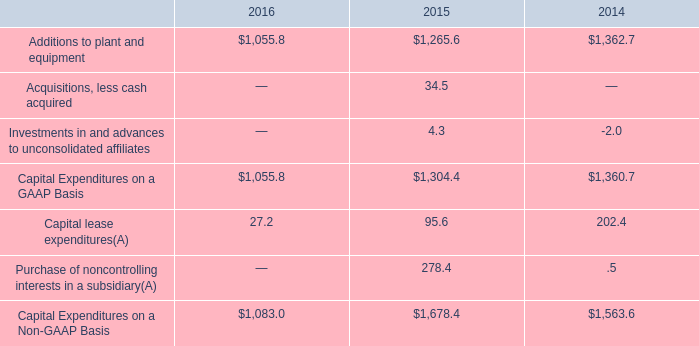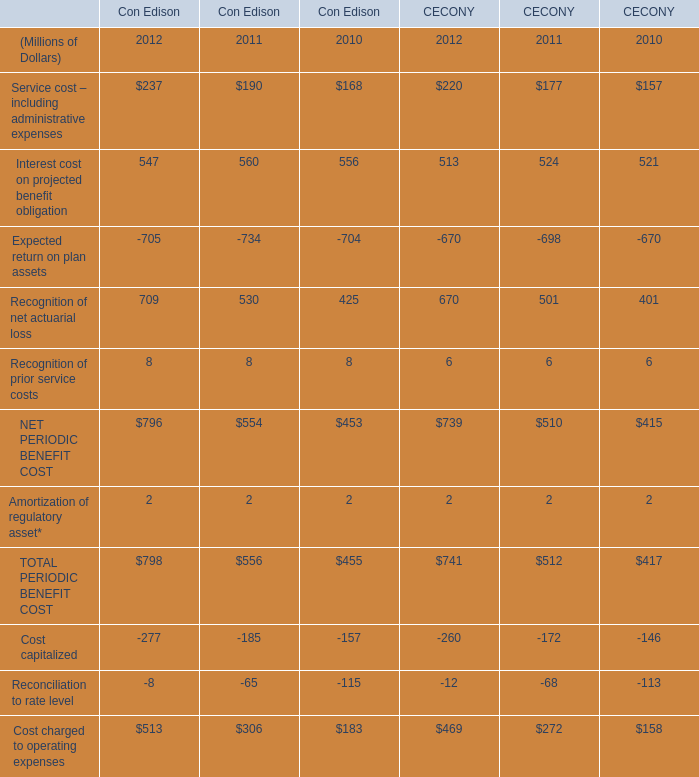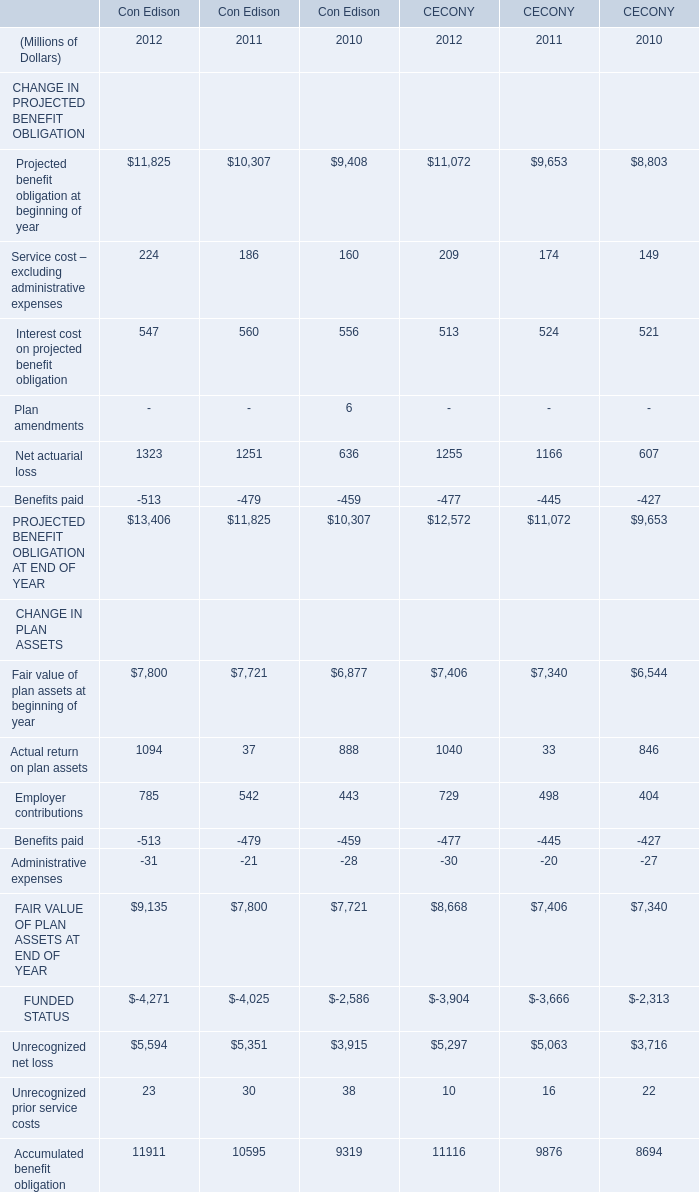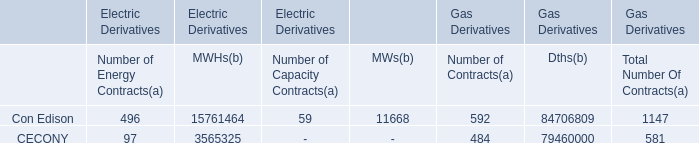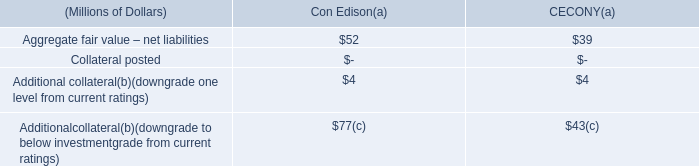What is the sum of FUNDED STATUS CHANGE IN PLAN ASSETS of CECONY 2010, Capital Expenditures on a GAAP Basis of 2016, and FAIR VALUE OF PLAN ASSETS AT END OF YEAR CHANGE IN PLAN ASSETS of Con Edison 2011 ? 
Computations: ((2313.0 + 1055.8) + 7800.0)
Answer: 11168.8. 